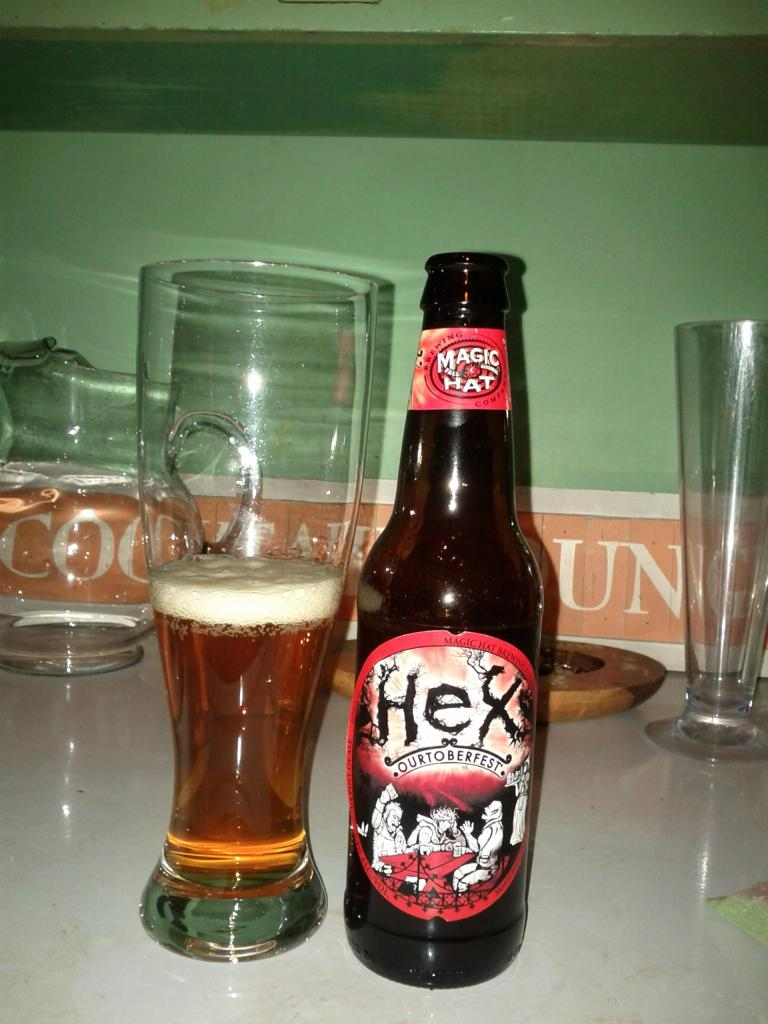Provide a one-sentence caption for the provided image. a beer bottle with the word Hex on it next to a glass. 